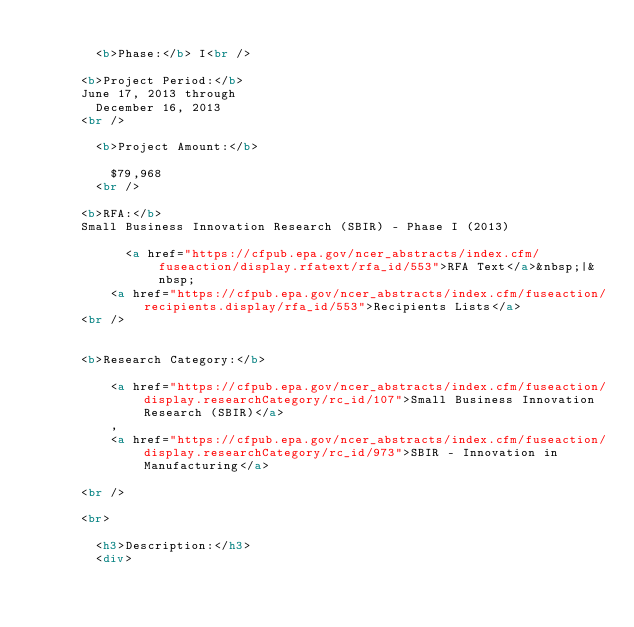Convert code to text. <code><loc_0><loc_0><loc_500><loc_500><_HTML_>      
        <b>Phase:</b> I<br />
      
      <b>Project Period:</b>
      June 17, 2013 through
        December 16, 2013 
      <br />
    
        <b>Project Amount:</b>
        
          $79,968 
        <br />
      
      <b>RFA:</b>
      Small Business Innovation Research (SBIR) - Phase I (2013) 
          	
        		<a href="https://cfpub.epa.gov/ncer_abstracts/index.cfm/fuseaction/display.rfatext/rfa_id/553">RFA Text</a>&nbsp;|&nbsp; 
          <a href="https://cfpub.epa.gov/ncer_abstracts/index.cfm/fuseaction/recipients.display/rfa_id/553">Recipients Lists</a> 
      <br />

      
      <b>Research Category:</b>
      
          <a href="https://cfpub.epa.gov/ncer_abstracts/index.cfm/fuseaction/display.researchCategory/rc_id/107">Small Business Innovation Research (SBIR)</a>
          , 
          <a href="https://cfpub.epa.gov/ncer_abstracts/index.cfm/fuseaction/display.researchCategory/rc_id/973">SBIR - Innovation in Manufacturing</a>
          
      <br />
    
      <br>
      
        <h3>Description:</h3>
      	<div></code> 